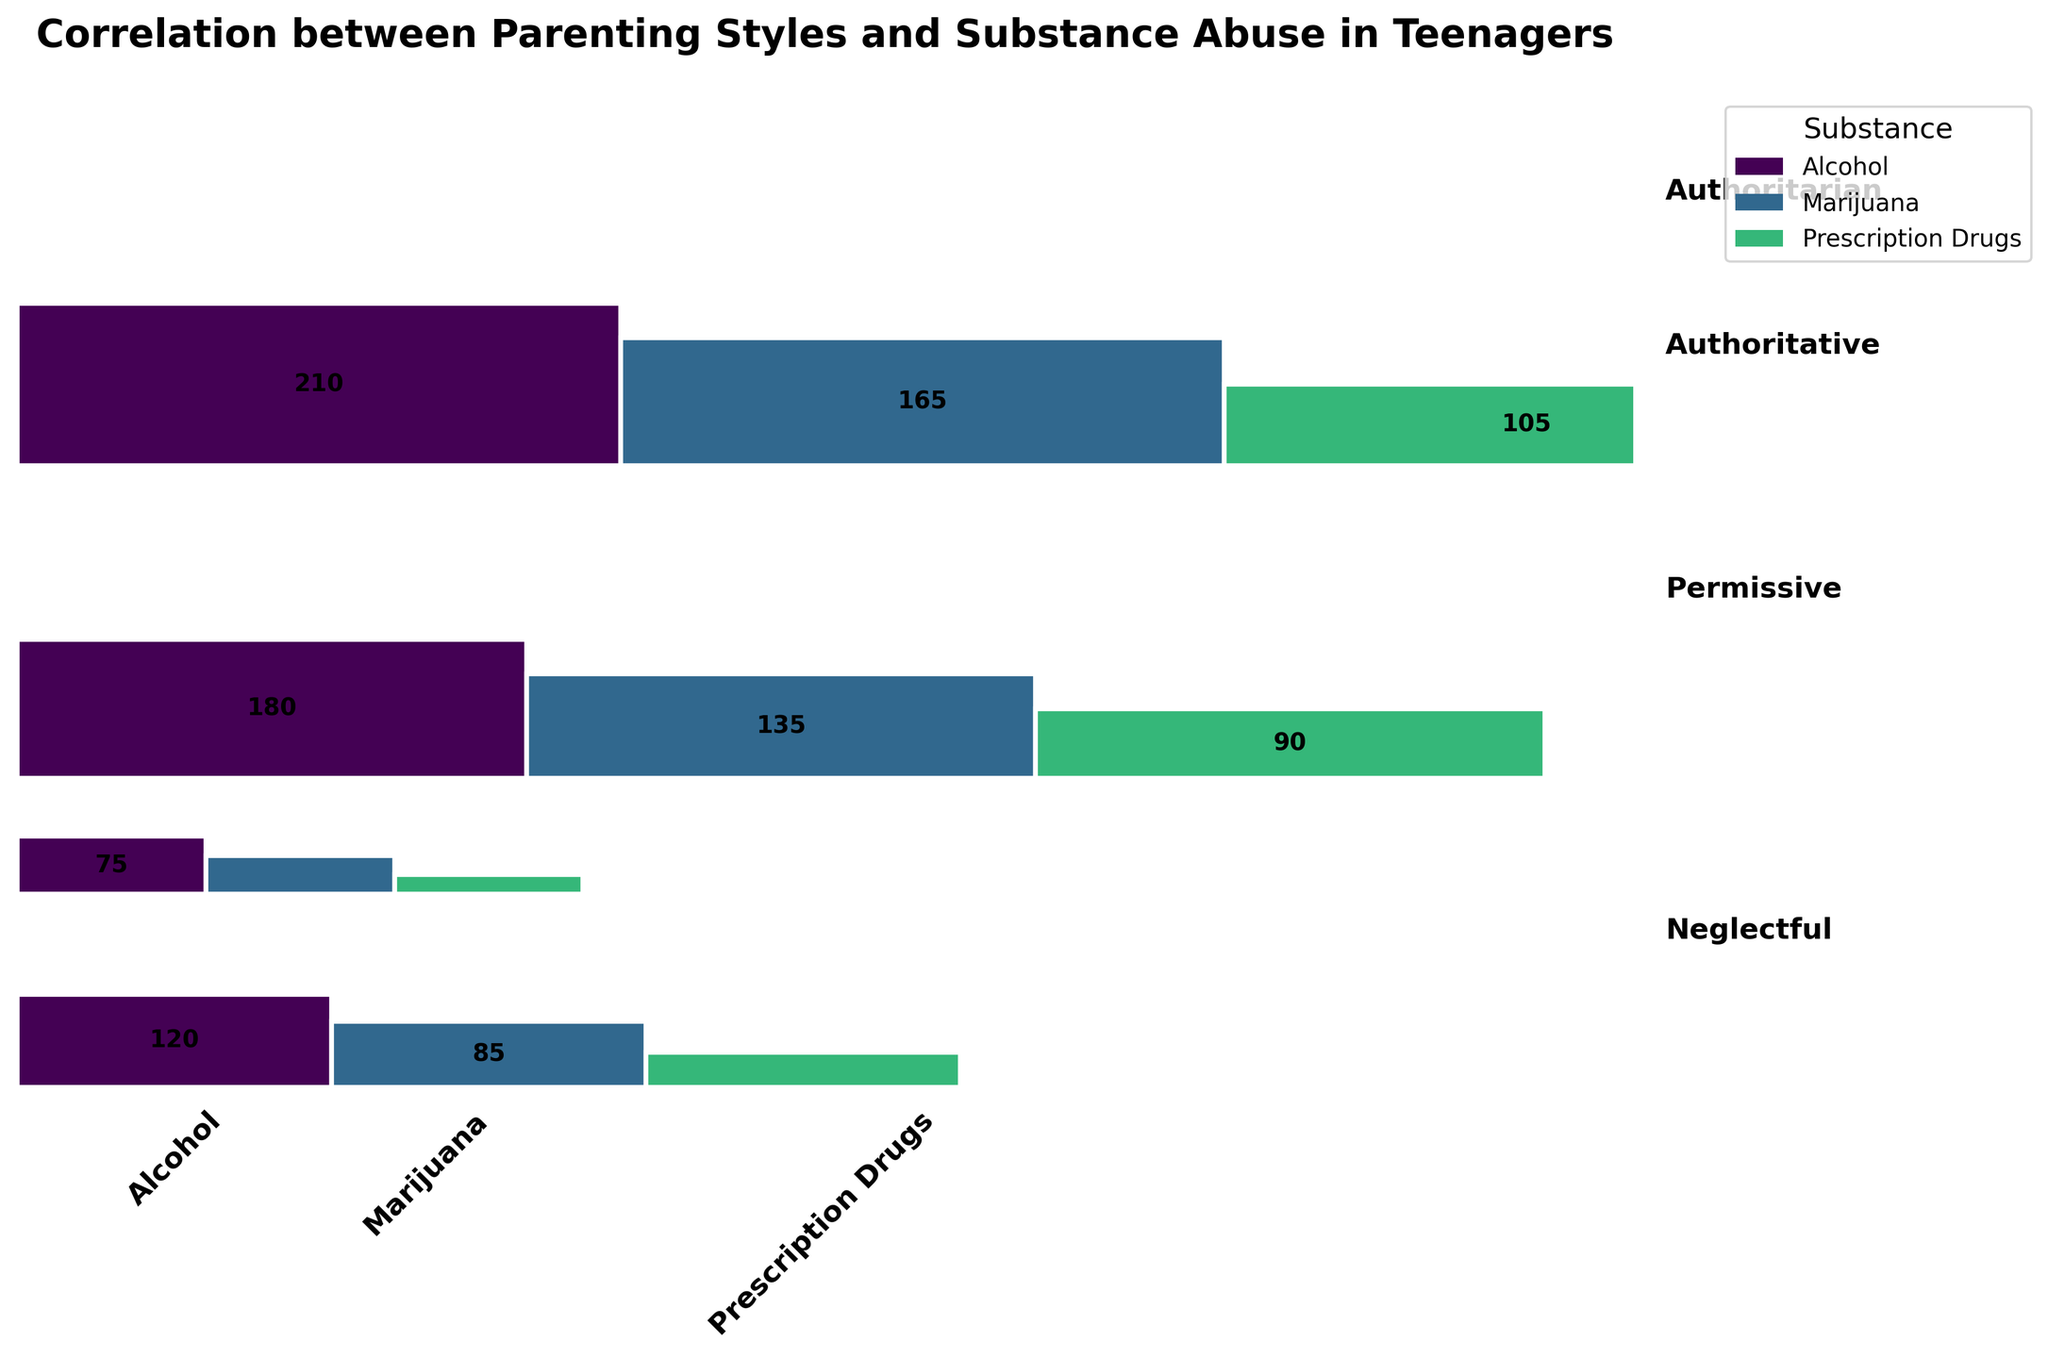What is the title of the plot? The title of the plot is displayed at the top, summarizing the plot's subject. The text in bold reads "Correlation between Parenting Styles and Substance Abuse in Teenagers".
Answer: Correlation between Parenting Styles and Substance Abuse in Teenagers Which parenting style has the highest frequency of substance abuse cases? To find out which parenting style has the highest frequency of substance abuse cases, add the frequencies of all substance abuse types for each parenting style. The plot clearly shows that the Neglectful parenting style has the largest area, meaning the highest total frequency when compared to other styles.
Answer: Neglectful What substance abuse case has the highest frequency under the Permissive parenting style? Look at the sections corresponding to the Permissive parenting style. Within the Permissive category's segments for Alcohol, Marijuana, and Prescription Drugs, the Alcohol section is the largest, indicating it has the highest frequency.
Answer: Alcohol Compare the prevalence of Alcohol abuse between Authoritarian and Neglectful parenting styles. The rectangles for Alcohol abuse under Authoritarian and Neglectful parenting styles can be compared in size. The rectangle for Alcohol abuse under Neglectful is larger than that under Authoritarian, indicating a higher frequency.
Answer: Higher in Neglectful What is the total frequency of Prescription Drugs abuse across all parenting styles? Sum the frequencies for Prescription Drugs abuse from each parenting style: 45 (Authoritarian) + 25 (Authoritative) + 90 (Permissive) + 105 (Neglectful). The answer is the sum of these frequencies.
Answer: 265 Which parenting style has the lowest frequency of Marijuana abuse cases? Identify the smallest rectangle corresponding to Marijuana abuse among the parenting styles. The plot shows that the Authoritative parenting style has the smallest segment for Marijuana abuse, indicating the lowest frequency.
Answer: Authoritative How does the frequency of Marijuana abuse under Permissive compare to Authoritative? Compare the areas of the rectangles for Marijuana under the Permissive and Authoritative styles. The rectangle for Permissive is larger, showing a higher frequency compared to Authoritative.
Answer: Higher in Permissive What are the three substances represented in the plot? Look at the labels on the x-axis or the legend. The substances are Alcohol, Marijuana, and Prescription Drugs. This can be verified by the respective colors and labels.
Answer: Alcohol, Marijuana, Prescription Drugs How does the ratio of Alcohol abuse to Prescription Drug abuse differ between Permissive and Authoritative parenting styles? Calculate the ratio of frequencies for Alcohol to Prescription Drugs for both parenting styles. For Permissive: 180/90 = 2. For Authoritative: 75/25 = 3. Compare these ratios to see the difference.
Answer: Higher ratio in Authoritative 